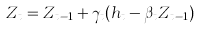<formula> <loc_0><loc_0><loc_500><loc_500>Z _ { t } = Z _ { t - 1 } + \gamma _ { t } ( h _ { t } - \beta _ { t } Z _ { t - 1 } )</formula> 